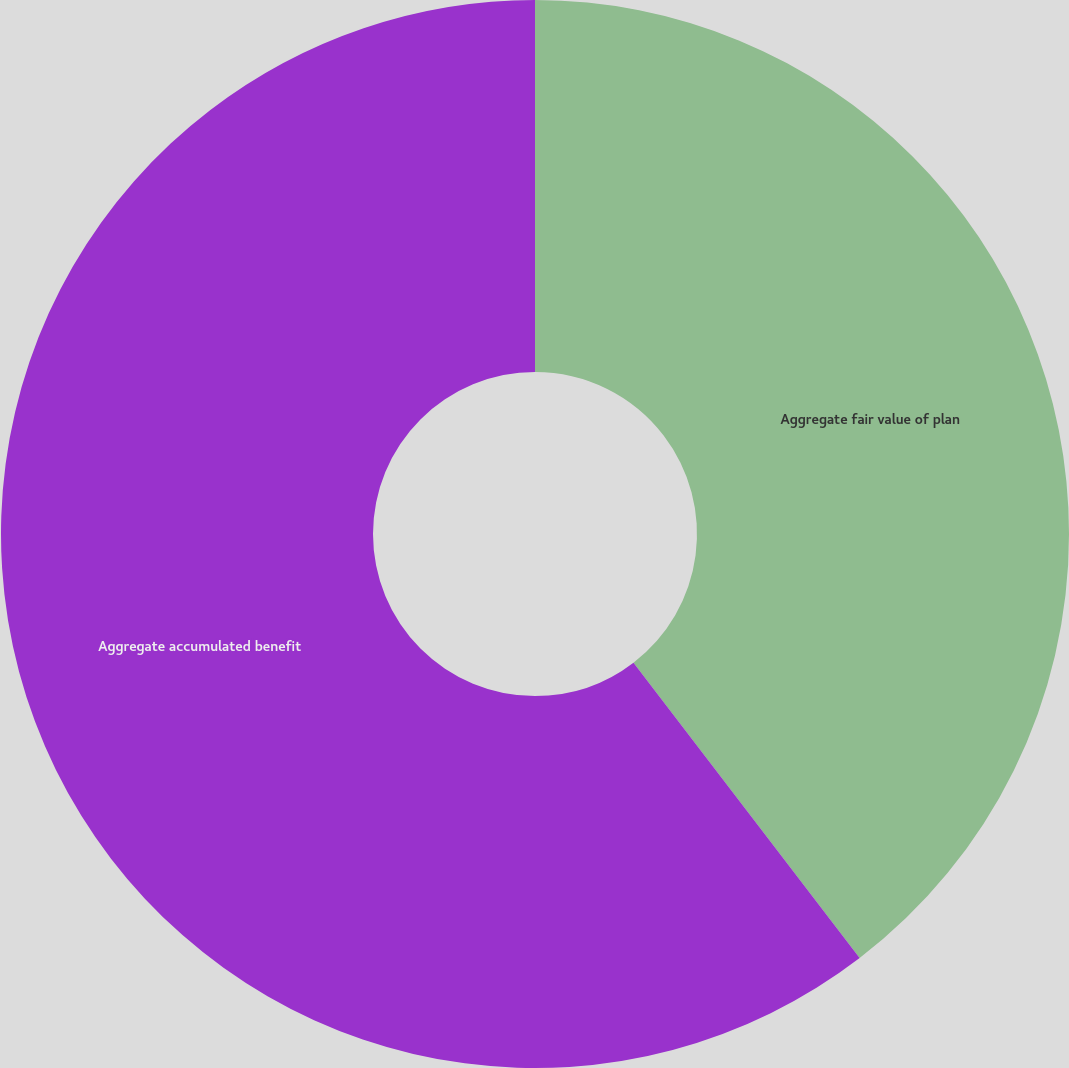Convert chart to OTSL. <chart><loc_0><loc_0><loc_500><loc_500><pie_chart><fcel>Aggregate fair value of plan<fcel>Aggregate accumulated benefit<nl><fcel>39.6%<fcel>60.4%<nl></chart> 